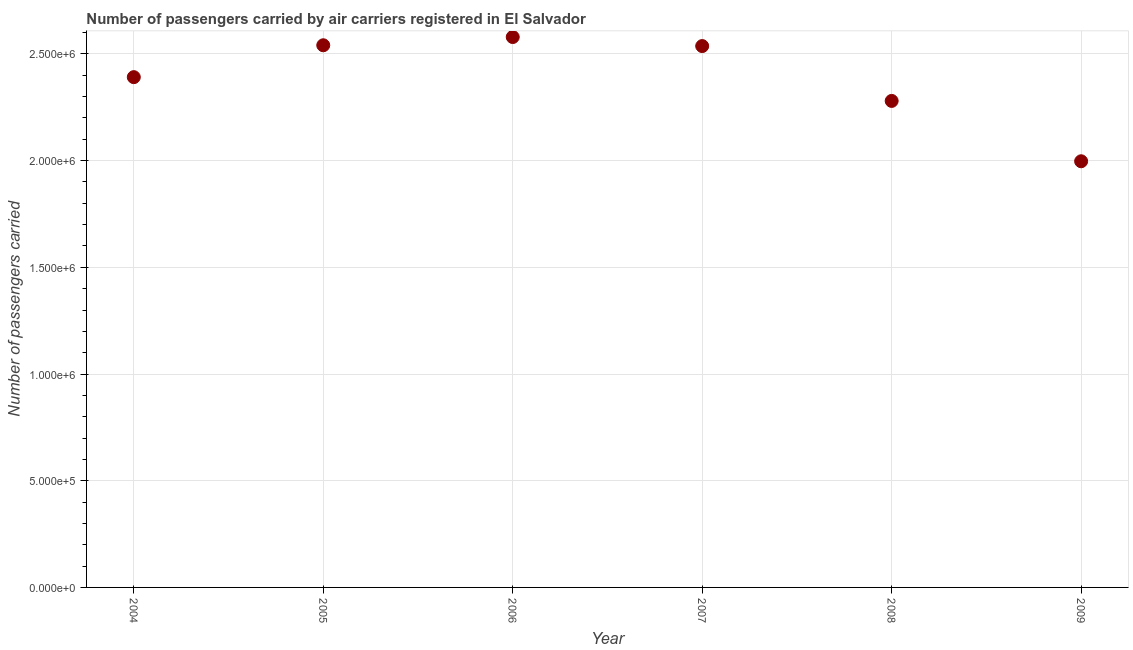What is the number of passengers carried in 2007?
Your response must be concise. 2.54e+06. Across all years, what is the maximum number of passengers carried?
Provide a short and direct response. 2.58e+06. Across all years, what is the minimum number of passengers carried?
Provide a succinct answer. 2.00e+06. In which year was the number of passengers carried maximum?
Make the answer very short. 2006. In which year was the number of passengers carried minimum?
Offer a very short reply. 2009. What is the sum of the number of passengers carried?
Ensure brevity in your answer.  1.43e+07. What is the difference between the number of passengers carried in 2004 and 2005?
Provide a succinct answer. -1.49e+05. What is the average number of passengers carried per year?
Offer a terse response. 2.39e+06. What is the median number of passengers carried?
Your answer should be compact. 2.46e+06. In how many years, is the number of passengers carried greater than 400000 ?
Your answer should be very brief. 6. Do a majority of the years between 2005 and 2007 (inclusive) have number of passengers carried greater than 1200000 ?
Offer a very short reply. Yes. What is the ratio of the number of passengers carried in 2004 to that in 2008?
Provide a short and direct response. 1.05. Is the difference between the number of passengers carried in 2005 and 2006 greater than the difference between any two years?
Offer a very short reply. No. What is the difference between the highest and the second highest number of passengers carried?
Offer a terse response. 3.86e+04. Is the sum of the number of passengers carried in 2007 and 2009 greater than the maximum number of passengers carried across all years?
Ensure brevity in your answer.  Yes. What is the difference between the highest and the lowest number of passengers carried?
Ensure brevity in your answer.  5.82e+05. In how many years, is the number of passengers carried greater than the average number of passengers carried taken over all years?
Your answer should be compact. 4. How many dotlines are there?
Your response must be concise. 1. What is the difference between two consecutive major ticks on the Y-axis?
Your response must be concise. 5.00e+05. Are the values on the major ticks of Y-axis written in scientific E-notation?
Offer a terse response. Yes. Does the graph contain any zero values?
Provide a short and direct response. No. What is the title of the graph?
Your answer should be compact. Number of passengers carried by air carriers registered in El Salvador. What is the label or title of the Y-axis?
Give a very brief answer. Number of passengers carried. What is the Number of passengers carried in 2004?
Offer a very short reply. 2.39e+06. What is the Number of passengers carried in 2005?
Keep it short and to the point. 2.54e+06. What is the Number of passengers carried in 2006?
Keep it short and to the point. 2.58e+06. What is the Number of passengers carried in 2007?
Offer a terse response. 2.54e+06. What is the Number of passengers carried in 2008?
Offer a very short reply. 2.28e+06. What is the Number of passengers carried in 2009?
Provide a succinct answer. 2.00e+06. What is the difference between the Number of passengers carried in 2004 and 2005?
Provide a succinct answer. -1.49e+05. What is the difference between the Number of passengers carried in 2004 and 2006?
Provide a short and direct response. -1.88e+05. What is the difference between the Number of passengers carried in 2004 and 2007?
Your response must be concise. -1.46e+05. What is the difference between the Number of passengers carried in 2004 and 2008?
Give a very brief answer. 1.11e+05. What is the difference between the Number of passengers carried in 2004 and 2009?
Offer a very short reply. 3.94e+05. What is the difference between the Number of passengers carried in 2005 and 2006?
Your answer should be very brief. -3.86e+04. What is the difference between the Number of passengers carried in 2005 and 2007?
Your response must be concise. 3744. What is the difference between the Number of passengers carried in 2005 and 2008?
Provide a succinct answer. 2.61e+05. What is the difference between the Number of passengers carried in 2005 and 2009?
Offer a very short reply. 5.44e+05. What is the difference between the Number of passengers carried in 2006 and 2007?
Make the answer very short. 4.23e+04. What is the difference between the Number of passengers carried in 2006 and 2008?
Provide a short and direct response. 2.99e+05. What is the difference between the Number of passengers carried in 2006 and 2009?
Give a very brief answer. 5.82e+05. What is the difference between the Number of passengers carried in 2007 and 2008?
Give a very brief answer. 2.57e+05. What is the difference between the Number of passengers carried in 2007 and 2009?
Offer a very short reply. 5.40e+05. What is the difference between the Number of passengers carried in 2008 and 2009?
Your response must be concise. 2.83e+05. What is the ratio of the Number of passengers carried in 2004 to that in 2005?
Your answer should be compact. 0.94. What is the ratio of the Number of passengers carried in 2004 to that in 2006?
Provide a succinct answer. 0.93. What is the ratio of the Number of passengers carried in 2004 to that in 2007?
Your answer should be very brief. 0.94. What is the ratio of the Number of passengers carried in 2004 to that in 2008?
Your response must be concise. 1.05. What is the ratio of the Number of passengers carried in 2004 to that in 2009?
Make the answer very short. 1.2. What is the ratio of the Number of passengers carried in 2005 to that in 2006?
Offer a terse response. 0.98. What is the ratio of the Number of passengers carried in 2005 to that in 2008?
Provide a succinct answer. 1.11. What is the ratio of the Number of passengers carried in 2005 to that in 2009?
Provide a succinct answer. 1.27. What is the ratio of the Number of passengers carried in 2006 to that in 2008?
Your answer should be compact. 1.13. What is the ratio of the Number of passengers carried in 2006 to that in 2009?
Offer a very short reply. 1.29. What is the ratio of the Number of passengers carried in 2007 to that in 2008?
Provide a succinct answer. 1.11. What is the ratio of the Number of passengers carried in 2007 to that in 2009?
Keep it short and to the point. 1.27. What is the ratio of the Number of passengers carried in 2008 to that in 2009?
Provide a succinct answer. 1.14. 